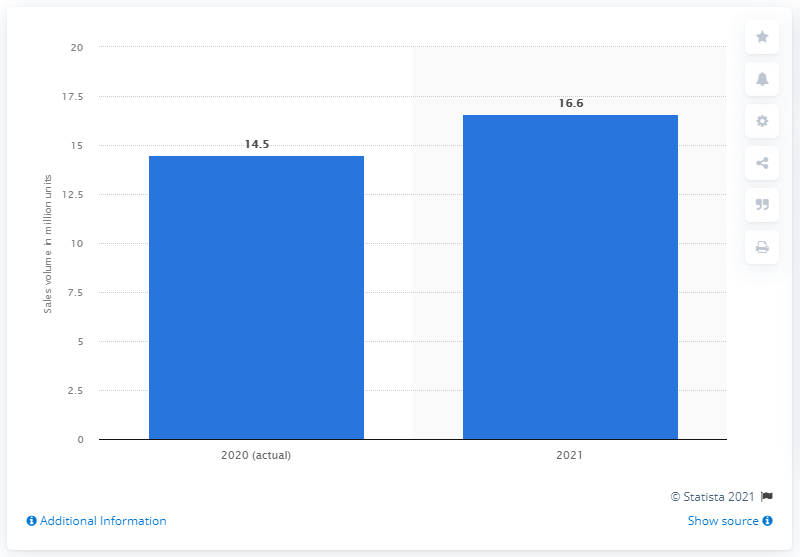Draw attention to some important aspects in this diagram. The U.S. auto industry is projected to sell a total of 16.6 vehicles between 2020 and 2021. 